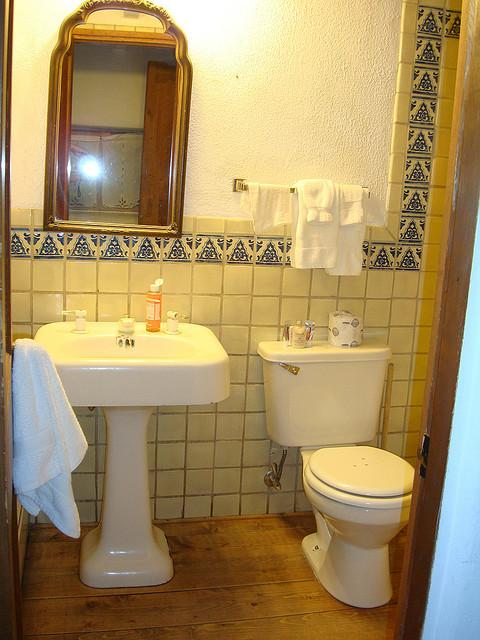Why do sanitary items comes in white color? Please explain your reasoning. cleanliness. They look clean when they are white and are easy to see the blemishes on them. 